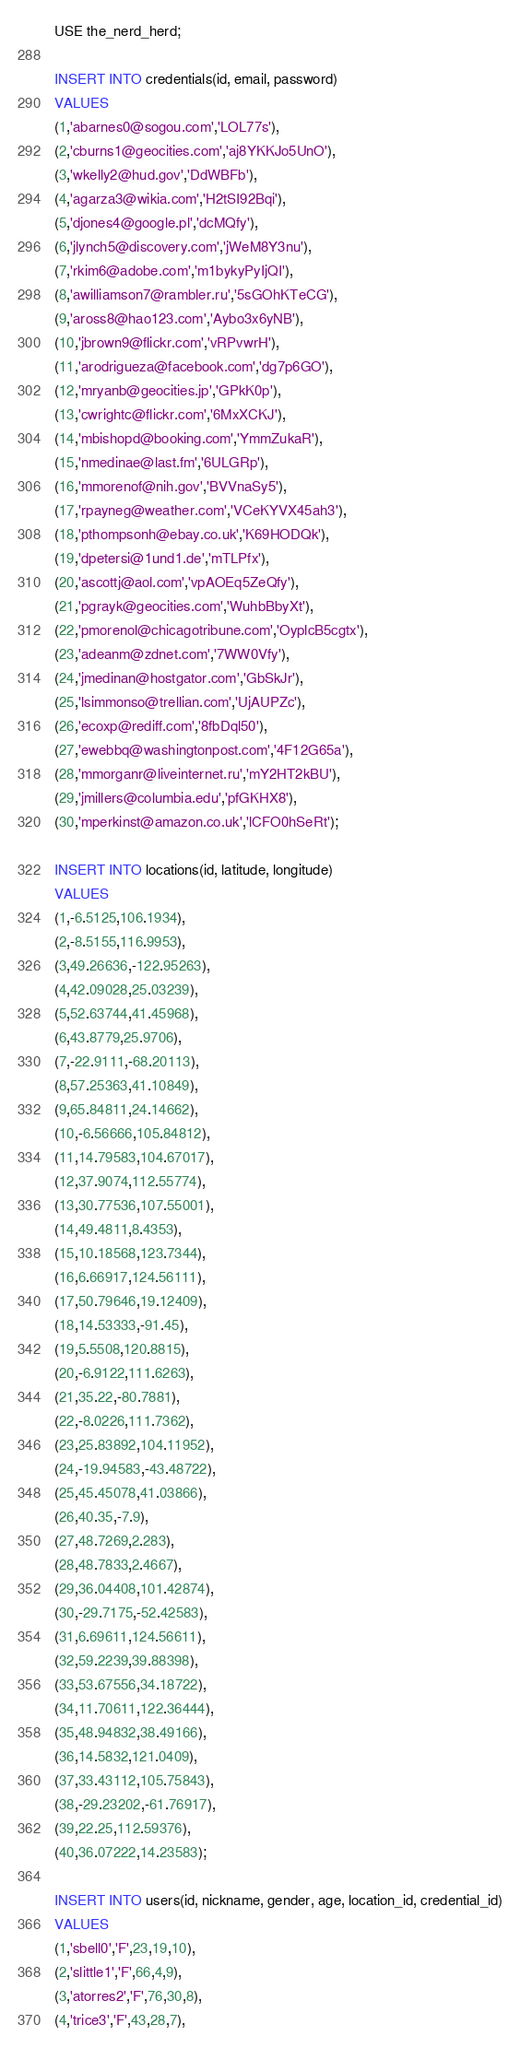<code> <loc_0><loc_0><loc_500><loc_500><_SQL_>USE the_nerd_herd;

INSERT INTO credentials(id, email, password)
VALUES
(1,'abarnes0@sogou.com','LOL77s'),
(2,'cburns1@geocities.com','aj8YKKJo5UnO'),
(3,'wkelly2@hud.gov','DdWBFb'),
(4,'agarza3@wikia.com','H2tSI92Bqi'),
(5,'djones4@google.pl','dcMQfy'),
(6,'jlynch5@discovery.com','jWeM8Y3nu'),
(7,'rkim6@adobe.com','m1bykyPyIjQI'),
(8,'awilliamson7@rambler.ru','5sGOhKTeCG'),
(9,'aross8@hao123.com','Aybo3x6yNB'),
(10,'jbrown9@flickr.com','vRPvwrH'),
(11,'arodrigueza@facebook.com','dg7p6GO'),
(12,'mryanb@geocities.jp','GPkK0p'),
(13,'cwrightc@flickr.com','6MxXCKJ'),
(14,'mbishopd@booking.com','YmmZukaR'),
(15,'nmedinae@last.fm','6ULGRp'),
(16,'mmorenof@nih.gov','BVVnaSy5'),
(17,'rpayneg@weather.com','VCeKYVX45ah3'),
(18,'pthompsonh@ebay.co.uk','K69HODQk'),
(19,'dpetersi@1und1.de','mTLPfx'),
(20,'ascottj@aol.com','vpAOEq5ZeQfy'),
(21,'pgrayk@geocities.com','WuhbBbyXt'),
(22,'pmorenol@chicagotribune.com','OyplcB5cgtx'),
(23,'adeanm@zdnet.com','7WW0Vfy'),
(24,'jmedinan@hostgator.com','GbSkJr'),
(25,'lsimmonso@trellian.com','UjAUPZc'),
(26,'ecoxp@rediff.com','8fbDql50'),
(27,'ewebbq@washingtonpost.com','4F12G65a'),
(28,'mmorganr@liveinternet.ru','mY2HT2kBU'),
(29,'jmillers@columbia.edu','pfGKHX8'),
(30,'mperkinst@amazon.co.uk','lCFO0hSeRt');

INSERT INTO locations(id, latitude, longitude)
VALUES
(1,-6.5125,106.1934),
(2,-8.5155,116.9953),
(3,49.26636,-122.95263),
(4,42.09028,25.03239),
(5,52.63744,41.45968),
(6,43.8779,25.9706),
(7,-22.9111,-68.20113),
(8,57.25363,41.10849),
(9,65.84811,24.14662),
(10,-6.56666,105.84812),
(11,14.79583,104.67017),
(12,37.9074,112.55774),
(13,30.77536,107.55001),
(14,49.4811,8.4353),
(15,10.18568,123.7344),
(16,6.66917,124.56111),
(17,50.79646,19.12409),
(18,14.53333,-91.45),
(19,5.5508,120.8815),
(20,-6.9122,111.6263),
(21,35.22,-80.7881),
(22,-8.0226,111.7362),
(23,25.83892,104.11952),
(24,-19.94583,-43.48722),
(25,45.45078,41.03866),
(26,40.35,-7.9),
(27,48.7269,2.283),
(28,48.7833,2.4667),
(29,36.04408,101.42874),
(30,-29.7175,-52.42583),
(31,6.69611,124.56611),
(32,59.2239,39.88398),
(33,53.67556,34.18722),
(34,11.70611,122.36444),
(35,48.94832,38.49166),
(36,14.5832,121.0409),
(37,33.43112,105.75843),
(38,-29.23202,-61.76917),
(39,22.25,112.59376),
(40,36.07222,14.23583);

INSERT INTO users(id, nickname, gender, age, location_id, credential_id)
VALUES
(1,'sbell0','F',23,19,10),
(2,'slittle1','F',66,4,9),
(3,'atorres2','F',76,30,8),
(4,'trice3','F',43,28,7),</code> 